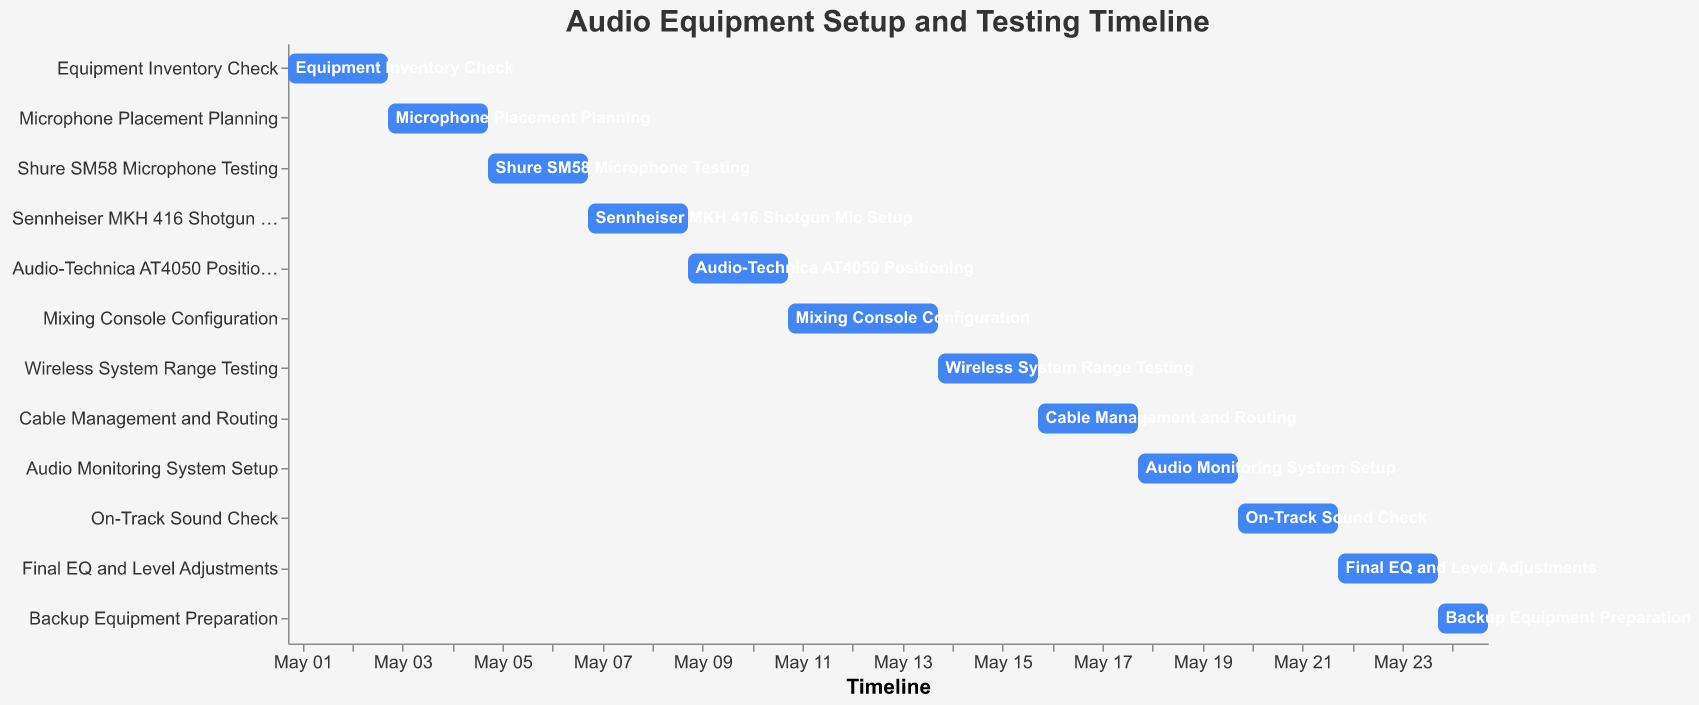What is the title of the Gantt Chart? The title is located at the top of the chart in a larger font than the rest and typically summarizes the content of the chart.
Answer: Audio Equipment Setup and Testing Timeline What color are the bars in the chart? The bars' color can be identified by simply looking at one of the bars.
Answer: Blue Which task takes place right after "Mixing Console Configuration"? Find "Mixing Console Configuration" on the Y-axis and check the next task listed immediately below it.
Answer: Wireless System Range Testing What's the duration of the "On-Track Sound Check" task? Check the start and end dates for "On-Track Sound Check" and calculate the difference in days.
Answer: 2 days Which task has the shortest duration? Compare all tasks' durations (difference between start and end dates) and find the smallest one.
Answer: Backup Equipment Preparation (1 day) How many tasks are planned for a duration of 3 days? Calculate the duration for each task by subtracting the start date from the end date and count those that result in 3 days.
Answer: 1 task How many tasks take place in May 2023? Identify tasks' start and end dates that fall between May 1st and May 31st. Count them.
Answer: 12 tasks Which task spans the longest period? Look at the bar lengths to find the task with the longest duration by comparing the start and end dates.
Answer: Mixing Console Configuration (3 days) Are there any tasks that start immediately after the previous task ends? Check if any task's start date is the same as the previous task's end date.
Answer: Yes Between which dates does the "Cable Management and Routing" task occur? Find "Cable Management and Routing" on the Y-axis and read off the start and end dates from the corresponding bar.
Answer: May 16 to May 18, 2023 